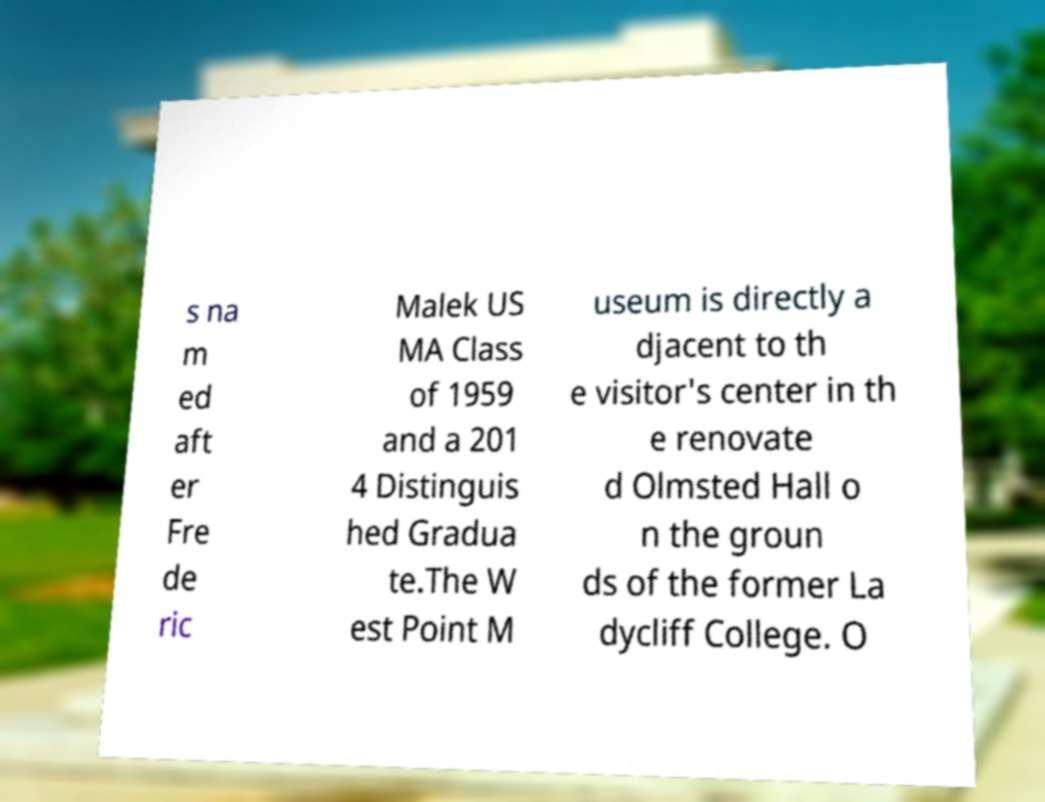Please read and relay the text visible in this image. What does it say? s na m ed aft er Fre de ric Malek US MA Class of 1959 and a 201 4 Distinguis hed Gradua te.The W est Point M useum is directly a djacent to th e visitor's center in th e renovate d Olmsted Hall o n the groun ds of the former La dycliff College. O 